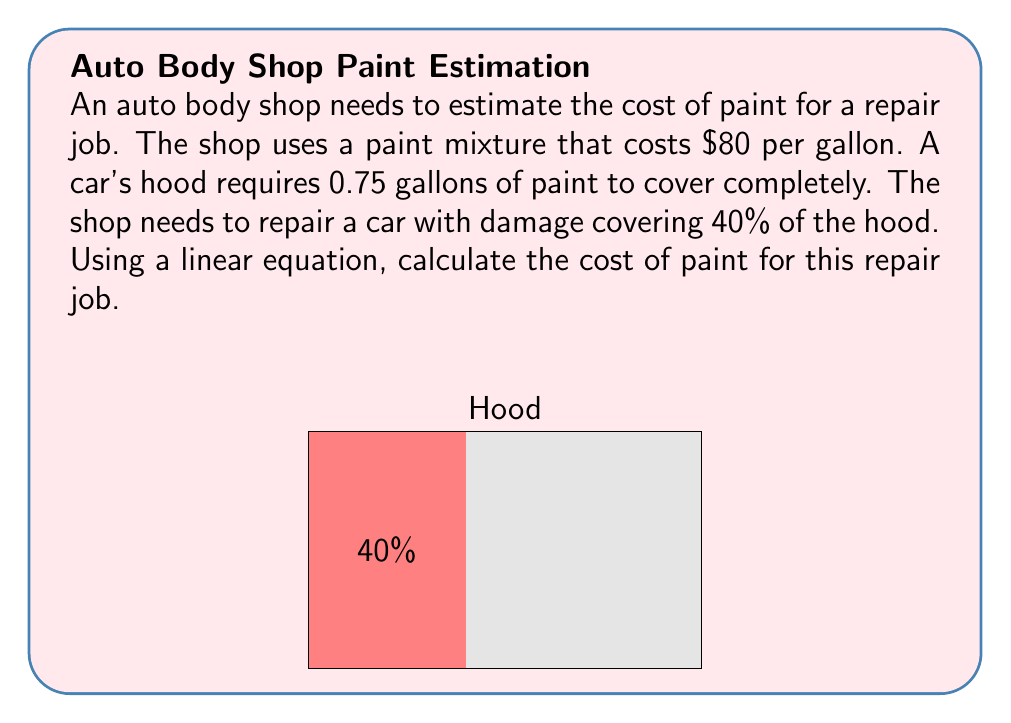Solve this math problem. Let's approach this step-by-step:

1) First, we need to set up our linear equation. Let $x$ be the amount of paint needed for the repair job in gallons, and $y$ be the cost in dollars.

2) We know that the full hood requires 0.75 gallons, and the damage covers 40% of the hood. We can set up a proportion:

   $$\frac{x}{0.75} = \frac{40}{100}$$

3) Solve for $x$:
   $$x = 0.75 \cdot \frac{40}{100} = 0.3 \text{ gallons}$$

4) Now we have the amount of paint needed. Let's set up our linear equation for cost:

   $$y = 80x$$

   Where 80 is the cost per gallon, and $x$ is the number of gallons.

5) Plug in our value for $x$:

   $$y = 80 \cdot 0.3 = 24$$

Therefore, the cost of paint for this repair job is $24.
Answer: $24 